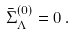<formula> <loc_0><loc_0><loc_500><loc_500>\bar { \Sigma } _ { \Lambda } ^ { ( 0 ) } = 0 \, .</formula> 